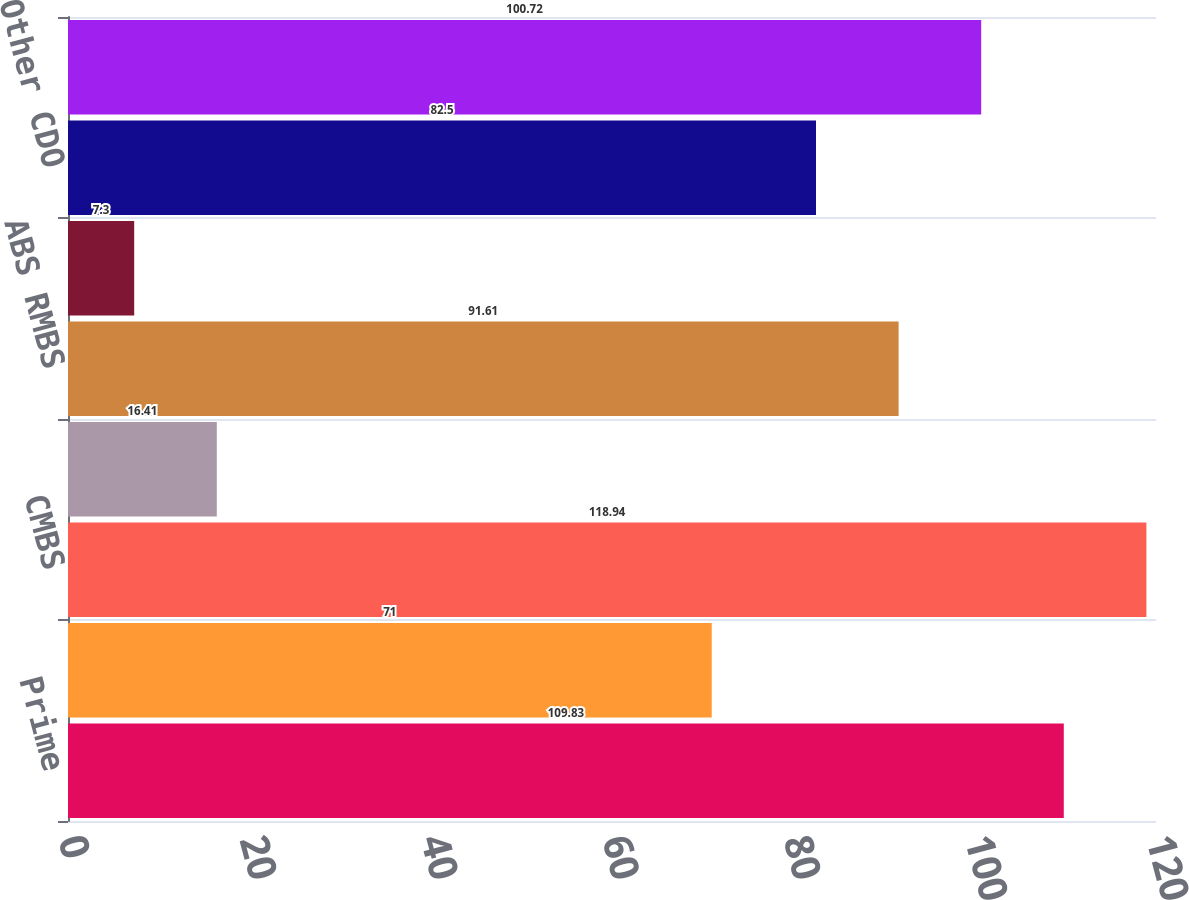<chart> <loc_0><loc_0><loc_500><loc_500><bar_chart><fcel>Prime<fcel>Alt-A<fcel>CMBS<fcel>CRE CDO<fcel>ABS RMBS<fcel>ABS CDO<fcel>Other CDO<fcel>Total<nl><fcel>109.83<fcel>71<fcel>118.94<fcel>16.41<fcel>91.61<fcel>7.3<fcel>82.5<fcel>100.72<nl></chart> 